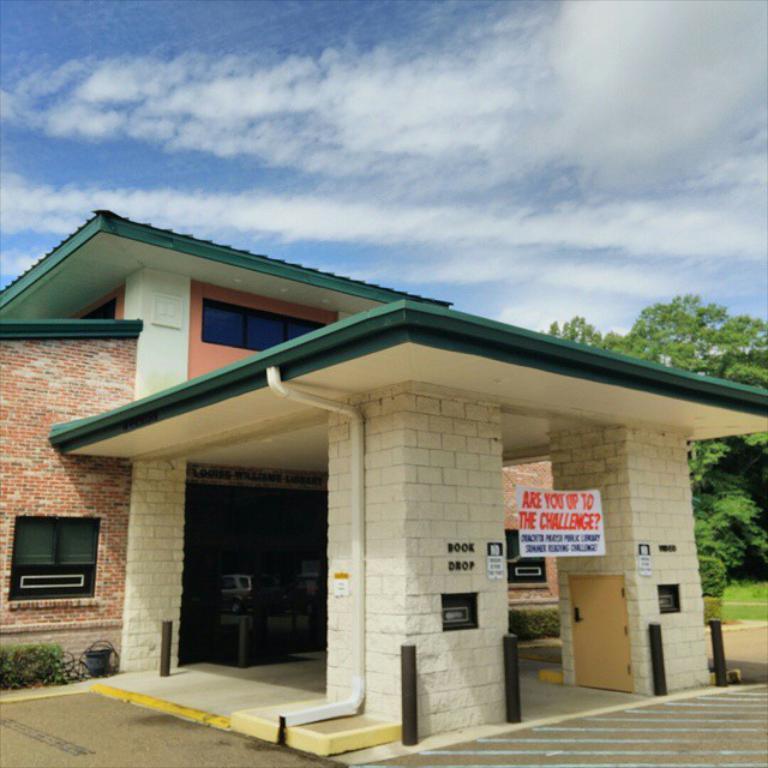Could you give a brief overview of what you see in this image? In this image I can see the building which is cream, green and brown in color, I can see few black colored poles, few trees which are green in color, few windows of the buildings, the cream colored door, the white colored banner and in the background I can see the sky. 